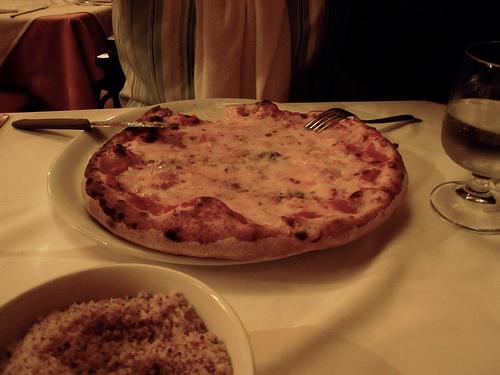What utensils are laying on the food?
Write a very short answer. Fork and knife. What kind of pattern would best be used to describe the tablecloth?
Answer briefly. Plain. What ingredients are on the pizza?
Short answer required. Cheese. Does this look delicious?
Short answer required. Yes. What beverage is in the glass?
Be succinct. Water. Is the table cloth cotton or man made fibers?
Keep it brief. Cotton. How many eating utensils are visible?
Short answer required. 2. 